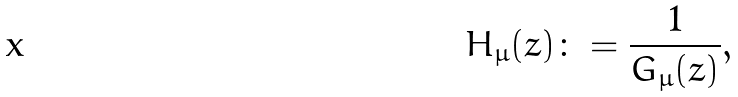Convert formula to latex. <formula><loc_0><loc_0><loc_500><loc_500>H _ { \mu } ( z ) \colon = \frac { 1 } { G _ { \mu } ( z ) } ,</formula> 